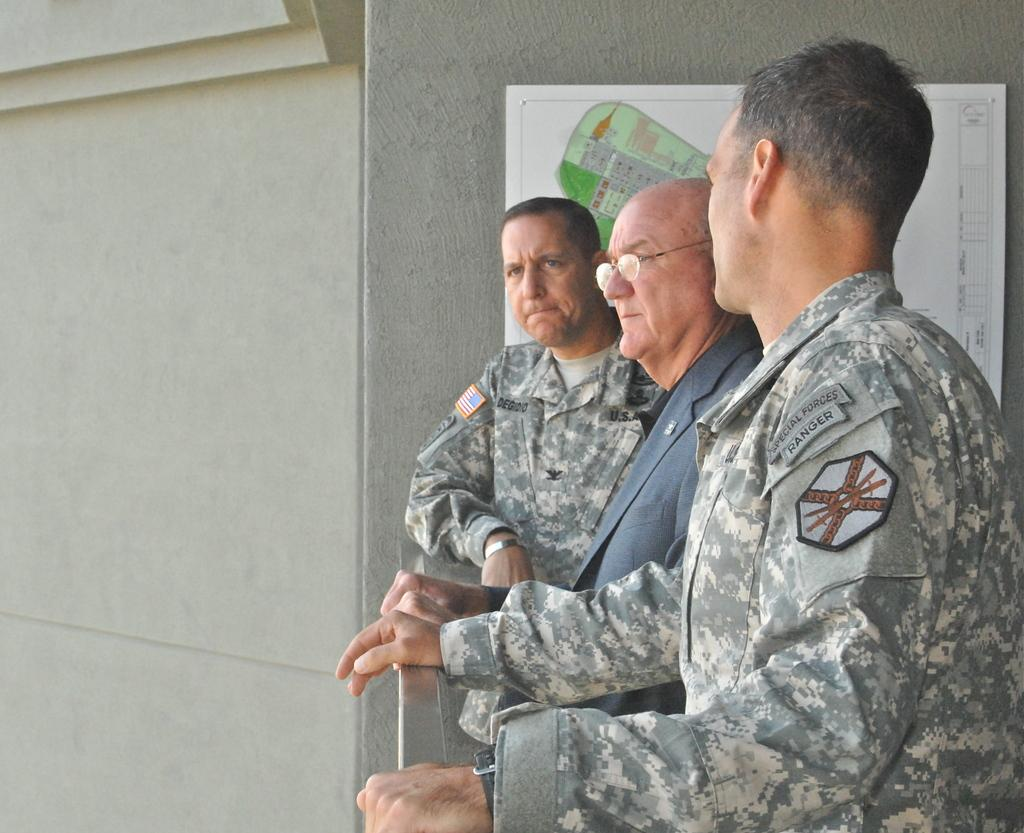How many people are in the image? There are three persons in the image. Where are the persons located in the image? The persons are standing in the right corner of the image. What can be seen beside the persons in the image? There is an object attached to the wall beside the persons. What type of apparel is the brain wearing in the image? There is no brain or apparel present in the image. What does the object attached to the wall beside the persons represent in the image? The provided facts do not specify what the object represents, so we cannot answer that question. 